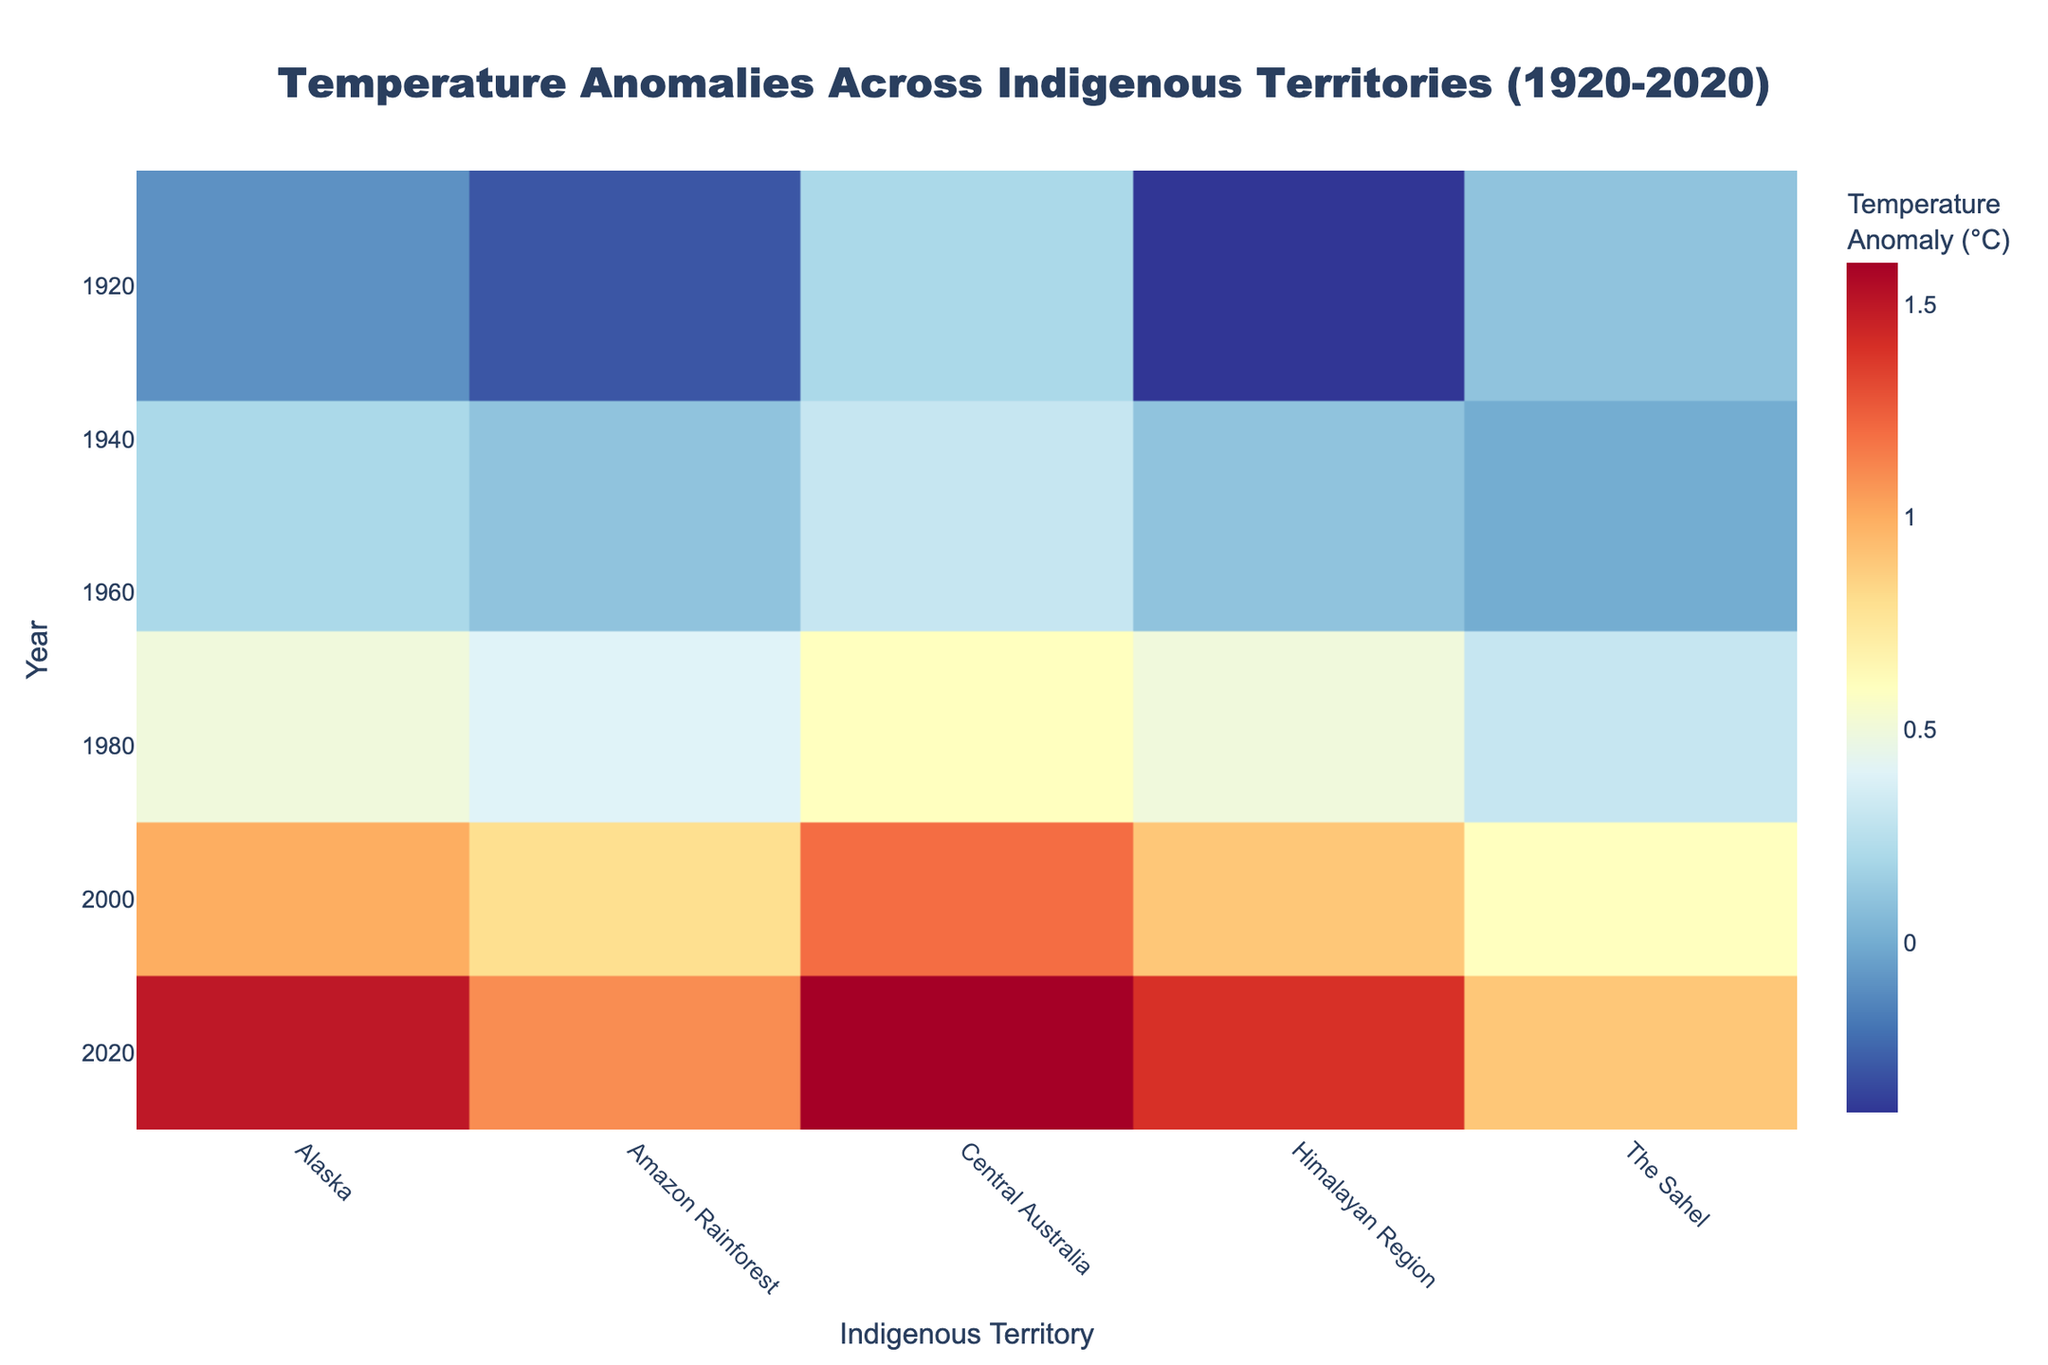What years are displayed on the Y-axis? The Y-axis of the heatmap represents the years over which the temperature anomalies were recorded. By looking at the figure, we can see the specific years labeled.
Answer: 1920, 1950, 1980, 2000, 2020 Which region shows the highest temperature anomaly in 2020? The heatmap depicts temperature anomalies across different regions and years. To find the highest anomaly for 2020, we locate the 2020 row and observe the values. The highest temperature anomaly color (dark red) corresponds to Central Australia.
Answer: Central Australia What is the average temperature anomaly for Alaska across all years? To find the average, we first locate the temperature anomaly values for the Alaska column and then calculate their average: (-0.1 + 0.2 + 0.5 + 1.0 + 1.5) / 5.
Answer: 0.62°C Which year shows the most significant increase in temperature anomaly for the Himalayan Region compared to the previous recorded year? Look at the values for the Himalayan Region across the years: 1920 (-0.4), 1950 (0.1), 1980 (0.5), 2000 (0.9), 2020 (1.4). Calculate the differences between successive years and find the maximum increase. The most significant increase is between 1920 and 1950: 0.1 - (-0.4) = 0.5.
Answer: 1950 Does any region show a cooling trend over the recorded years? Observe each region's temperature anomaly values across years to identify any downward trend. All regions show increasing temperature anomalies over time, indicating there is no cooling trend.
Answer: No Which region experienced the smallest temperature anomaly in 1980? Find the temperature anomaly values for all regions in 1980 and compare them. The smallest value (yellowish tone) corresponds to The Sahel with a value of 0.3°C.
Answer: The Sahel What is the total sum of temperature anomalies for the Amazon Rainforest over the recorded years? Summing the temperature anomalies for the Amazon Rainforest column: -0.3 + 0.1 + 0.4 + 0.8 + 1.1. Calculate the total sum: -0.3 + 0.1 + 0.4 + 0.8 + 1.1 = 2.1.
Answer: 2.1°C Which year depicts the highest temperature anomaly across all regions? By scanning through the plotted years, we identify the highest value present on the heatmap. The year 2020 shows the highest values for heat anomalies across various regions, with Central Australia having the highest value of 1.6°C.
Answer: 2020 